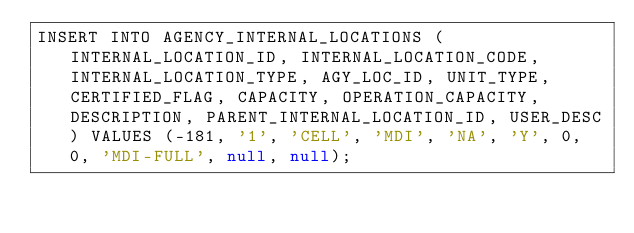Convert code to text. <code><loc_0><loc_0><loc_500><loc_500><_SQL_>INSERT INTO AGENCY_INTERNAL_LOCATIONS (INTERNAL_LOCATION_ID, INTERNAL_LOCATION_CODE, INTERNAL_LOCATION_TYPE, AGY_LOC_ID, UNIT_TYPE, CERTIFIED_FLAG, CAPACITY, OPERATION_CAPACITY, DESCRIPTION, PARENT_INTERNAL_LOCATION_ID, USER_DESC) VALUES (-181, '1', 'CELL', 'MDI', 'NA', 'Y', 0, 0, 'MDI-FULL', null, null);
</code> 